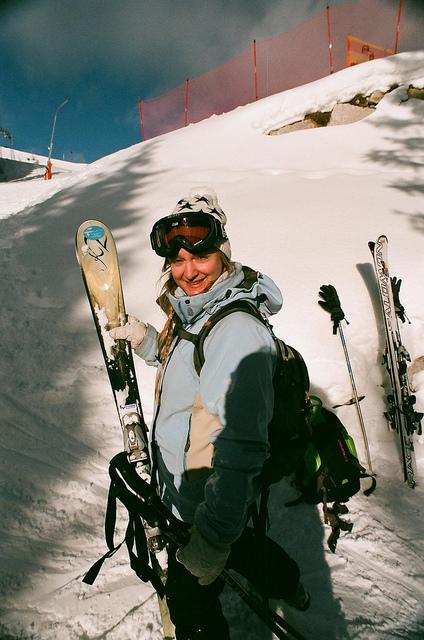What is she holding in her right hand?
Concise answer only. Ski. What was used to decorate the background graphic?
Be succinct. Nothing. Are the women's goggles over her eyes?
Write a very short answer. No. Is the lady smiling?
Answer briefly. Yes. Are the skiers real or painted?
Quick response, please. Real. 